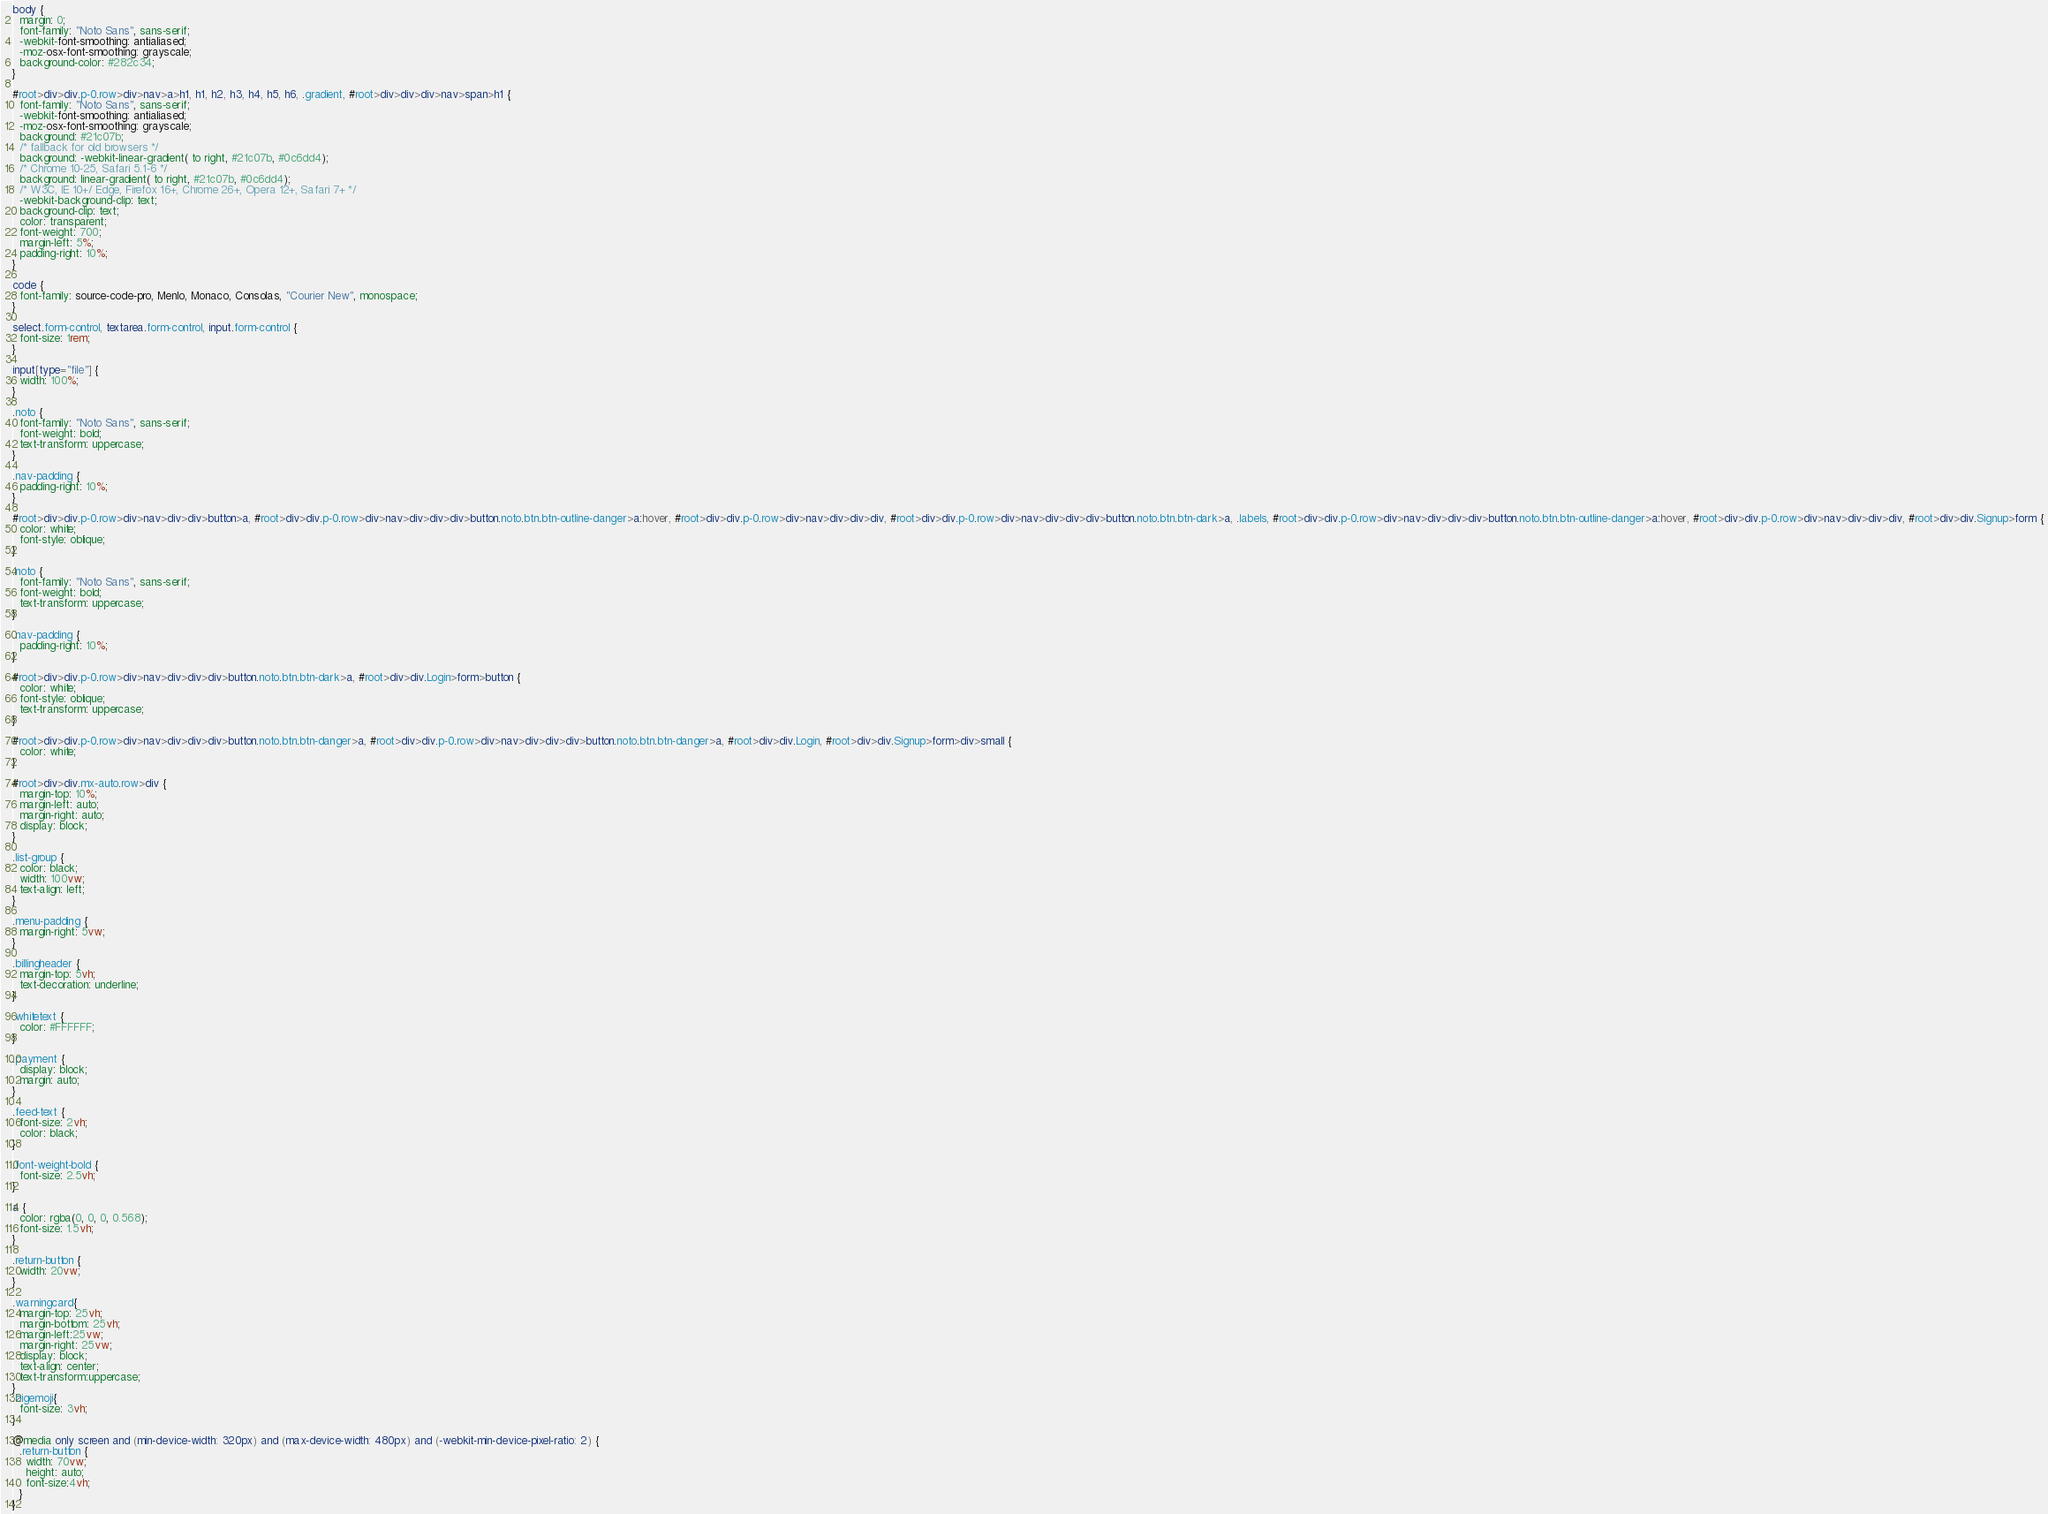<code> <loc_0><loc_0><loc_500><loc_500><_CSS_>body {
  margin: 0;
  font-family: "Noto Sans", sans-serif;
  -webkit-font-smoothing: antialiased;
  -moz-osx-font-smoothing: grayscale;
  background-color: #282c34;
}

#root>div>div.p-0.row>div>nav>a>h1, h1, h2, h3, h4, h5, h6, .gradient, #root>div>div>div>nav>span>h1 {
  font-family: "Noto Sans", sans-serif;
  -webkit-font-smoothing: antialiased;
  -moz-osx-font-smoothing: grayscale;
  background: #21c07b;
  /* fallback for old browsers */
  background: -webkit-linear-gradient( to right, #21c07b, #0c6dd4);
  /* Chrome 10-25, Safari 5.1-6 */
  background: linear-gradient( to right, #21c07b, #0c6dd4);
  /* W3C, IE 10+/ Edge, Firefox 16+, Chrome 26+, Opera 12+, Safari 7+ */
  -webkit-background-clip: text;
  background-clip: text;
  color: transparent;
  font-weight: 700;
  margin-left: 5%;
  padding-right: 10%;
}

code {
  font-family: source-code-pro, Menlo, Monaco, Consolas, "Courier New", monospace;
}

select.form-control, textarea.form-control, input.form-control {
  font-size: 1rem;
}

input[type="file"] {
  width: 100%;
}

.noto {
  font-family: "Noto Sans", sans-serif;
  font-weight: bold;
  text-transform: uppercase;
}

.nav-padding {
  padding-right: 10%;
}

#root>div>div.p-0.row>div>nav>div>div>button>a, #root>div>div.p-0.row>div>nav>div>div>div>button.noto.btn.btn-outline-danger>a:hover, #root>div>div.p-0.row>div>nav>div>div>div, #root>div>div.p-0.row>div>nav>div>div>div>button.noto.btn.btn-dark>a, .labels, #root>div>div.p-0.row>div>nav>div>div>div>button.noto.btn.btn-outline-danger>a:hover, #root>div>div.p-0.row>div>nav>div>div>div, #root>div>div.Signup>form {
  color: white;
  font-style: oblique;
}

.noto {
  font-family: "Noto Sans", sans-serif;
  font-weight: bold;
  text-transform: uppercase;
}

.nav-padding {
  padding-right: 10%;
}

#root>div>div.p-0.row>div>nav>div>div>div>button.noto.btn.btn-dark>a, #root>div>div.Login>form>button {
  color: white;
  font-style: oblique;
  text-transform: uppercase;
}

#root>div>div.p-0.row>div>nav>div>div>div>button.noto.btn.btn-danger>a, #root>div>div.p-0.row>div>nav>div>div>div>button.noto.btn.btn-danger>a, #root>div>div.Login, #root>div>div.Signup>form>div>small {
  color: white;
}

#root>div>div.mx-auto.row>div {
  margin-top: 10%;
  margin-left: auto;
  margin-right: auto;
  display: block;
}

.list-group {
  color: black;
  width: 100vw;
  text-align: left;
}

.menu-padding {
  margin-right: 5vw;
}

.billingheader {
  margin-top: 5vh;
  text-decoration: underline;
}

.whitetext {
  color: #FFFFFF;
}

.payment {
  display: block;
  margin: auto;
}

.feed-text {
  font-size: 2vh;
  color: black;
}

.font-weight-bold {
  font-size: 2.5vh;
}

a {
  color: rgba(0, 0, 0, 0.568);
  font-size: 1.5vh;
}

.return-button {
  width: 20vw;
}

.warningcard{
  margin-top: 25vh;
  margin-bottom: 25vh;
  margin-left:25vw;
  margin-right: 25vw;
  display: block;
  text-align: center;
  text-transform:uppercase;
}
.bigemoji{
  font-size: 3vh;
}

@media only screen and (min-device-width: 320px) and (max-device-width: 480px) and (-webkit-min-device-pixel-ratio: 2) {
  .return-button {
    width: 70vw;
    height: auto;
    font-size:4vh;
  }
}</code> 